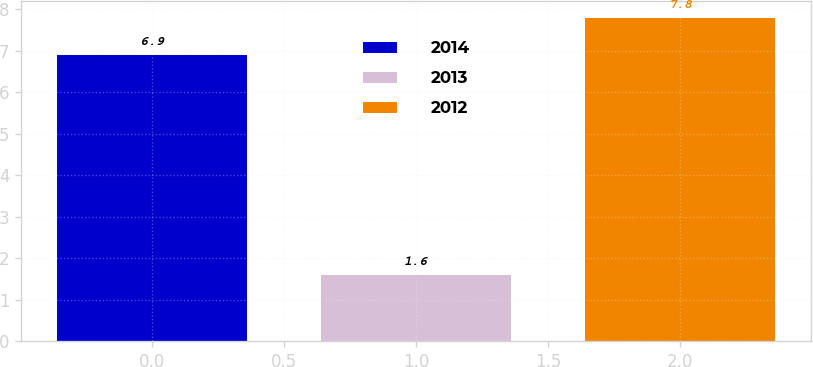<chart> <loc_0><loc_0><loc_500><loc_500><bar_chart><fcel>2014<fcel>2013<fcel>2012<nl><fcel>6.9<fcel>1.6<fcel>7.8<nl></chart> 